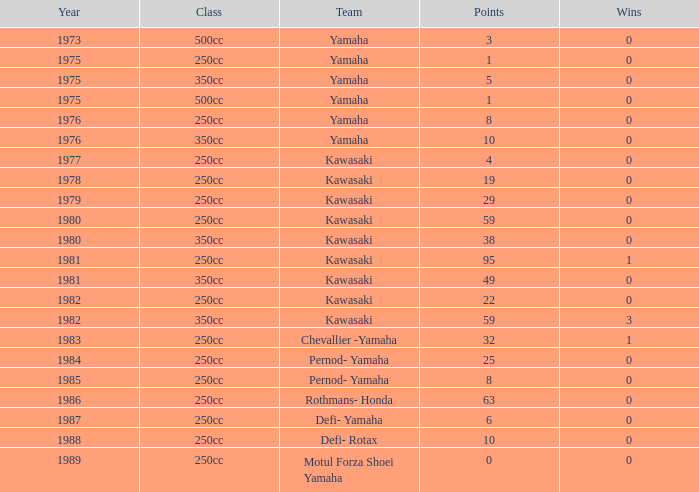With 95 points, what was the highest number of victories kawasaki achieved as a team in the year preceding 1981? None. 